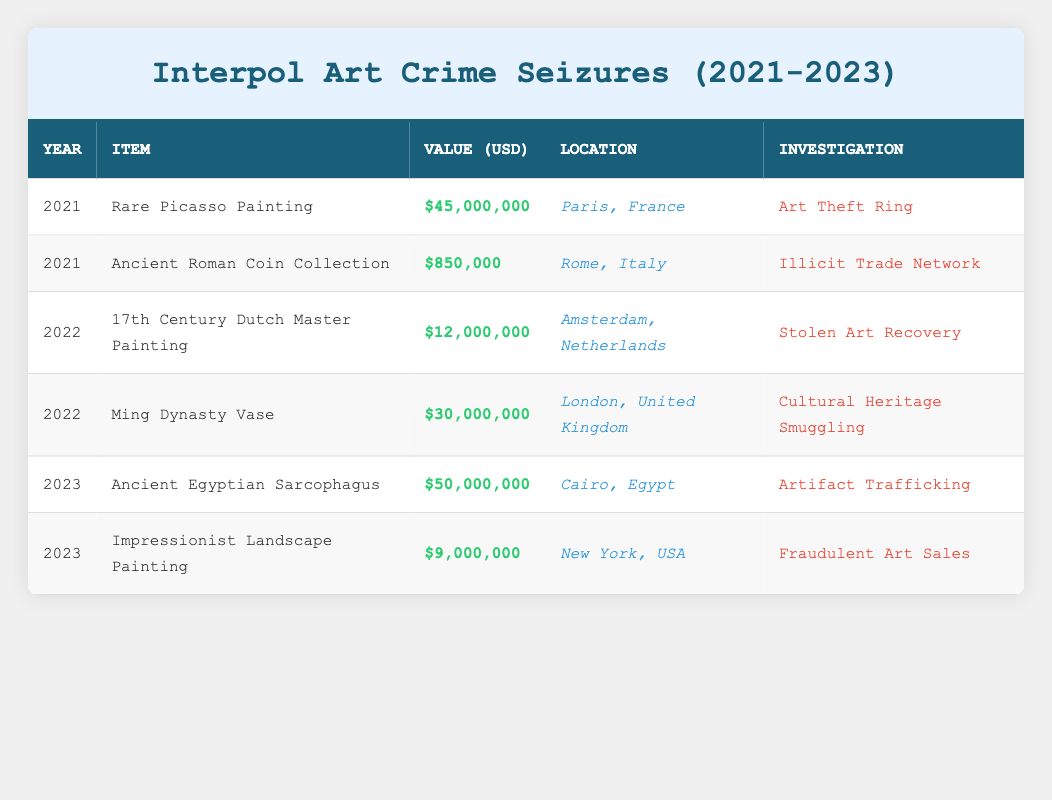What is the value of the Rare Picasso Painting? The table shows the value of the Rare Picasso Painting under the "Value (USD)" column for the year 2021. It indicates that the value is $45,000,000.
Answer: $45,000,000 Which item has the highest value in 2023? By examining the "Value (USD)" column for the year 2023, we can see that the Ancient Egyptian Sarcophagus has a value of $50,000,000, which is higher than the other item listed for that year.
Answer: Ancient Egyptian Sarcophagus What was the total value of art and antiques seized in 2022? To calculate the total value seized in 2022, we add the values for the items listed: $12,000,000 (17th Century Dutch Master Painting) + $30,000,000 (Ming Dynasty Vase) = $42,000,000.
Answer: $42,000,000 Was any item seized in 2021 with a value above $1 million? From the table, it shows that the Rare Picasso Painting, valued at $45,000,000, and the Ancient Roman Coin Collection, valued at $850,000, were seized in 2021. The only item above $1 million is the Rare Picasso Painting.
Answer: Yes In which location was the Ming Dynasty Vase seized? The table clearly specifies the location of the Ming Dynasty Vase, which is listed under the "Location" column for the year 2022 as London, United Kingdom.
Answer: London, United Kingdom What is the average value of items seized in 2023? The total value for the year 2023 is $50,000,000 (Ancient Egyptian Sarcophagus) + $9,000,000 (Impressionist Landscape Painting) = $59,000,000. There are two items, so the average is $59,000,000 / 2 = $29,500,000.
Answer: $29,500,000 